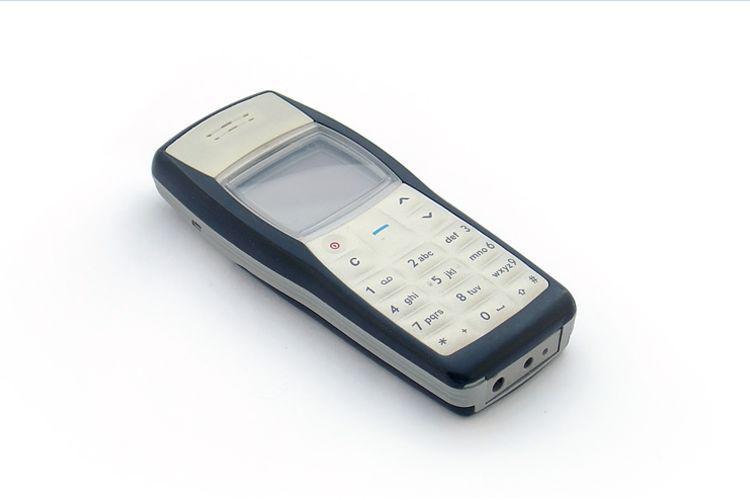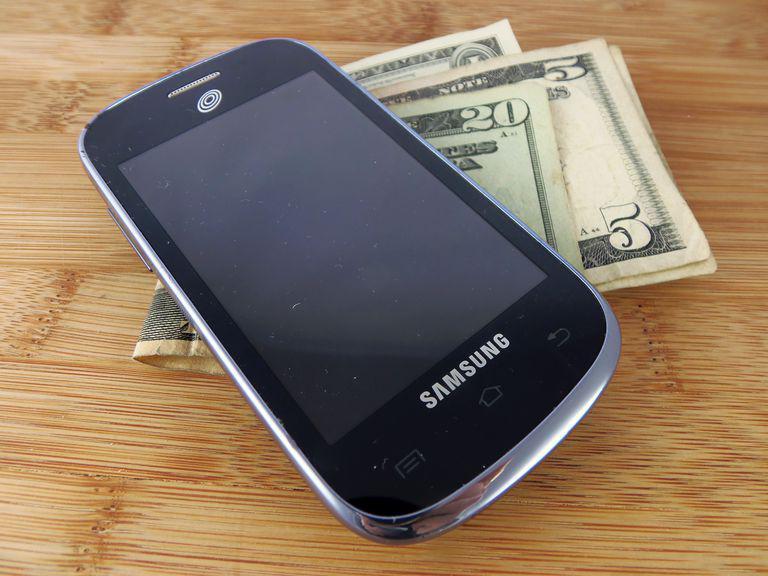The first image is the image on the left, the second image is the image on the right. Given the left and right images, does the statement "At least four phones are stacked on top of each other in at least one of the pictures." hold true? Answer yes or no. No. The first image is the image on the left, the second image is the image on the right. Analyze the images presented: Is the assertion "The right image contains a stack of four phones, with the phones stacked in a staggered fashion instead of aligned." valid? Answer yes or no. No. 